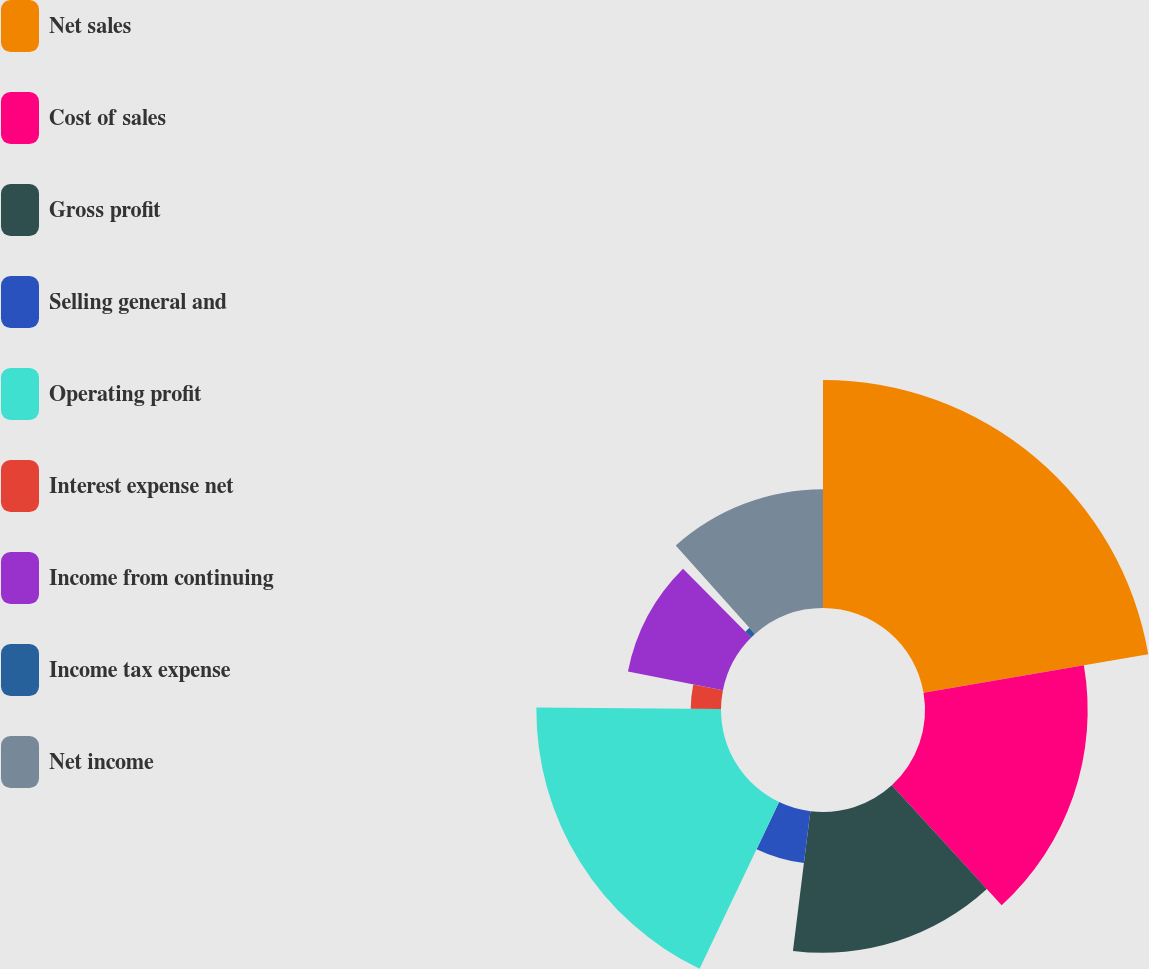Convert chart. <chart><loc_0><loc_0><loc_500><loc_500><pie_chart><fcel>Net sales<fcel>Cost of sales<fcel>Gross profit<fcel>Selling general and<fcel>Operating profit<fcel>Interest expense net<fcel>Income from continuing<fcel>Income tax expense<fcel>Net income<nl><fcel>22.3%<fcel>15.91%<fcel>13.77%<fcel>5.11%<fcel>18.06%<fcel>2.96%<fcel>9.47%<fcel>0.81%<fcel>11.62%<nl></chart> 